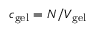Convert formula to latex. <formula><loc_0><loc_0><loc_500><loc_500>c _ { g e l } = N / V _ { g e l }</formula> 